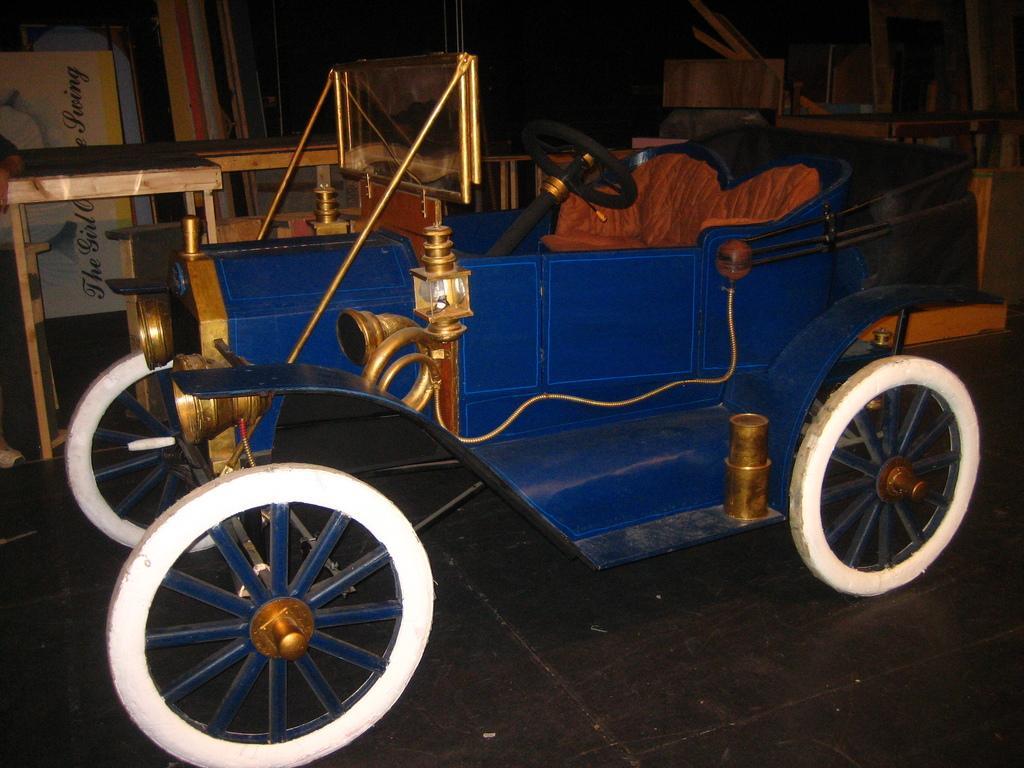Please provide a concise description of this image. In the center of the image we can see a vehicle. In the background of the image we can see the tables, boxes, wall and some other objects. At the bottom of the image we can see the floor. 